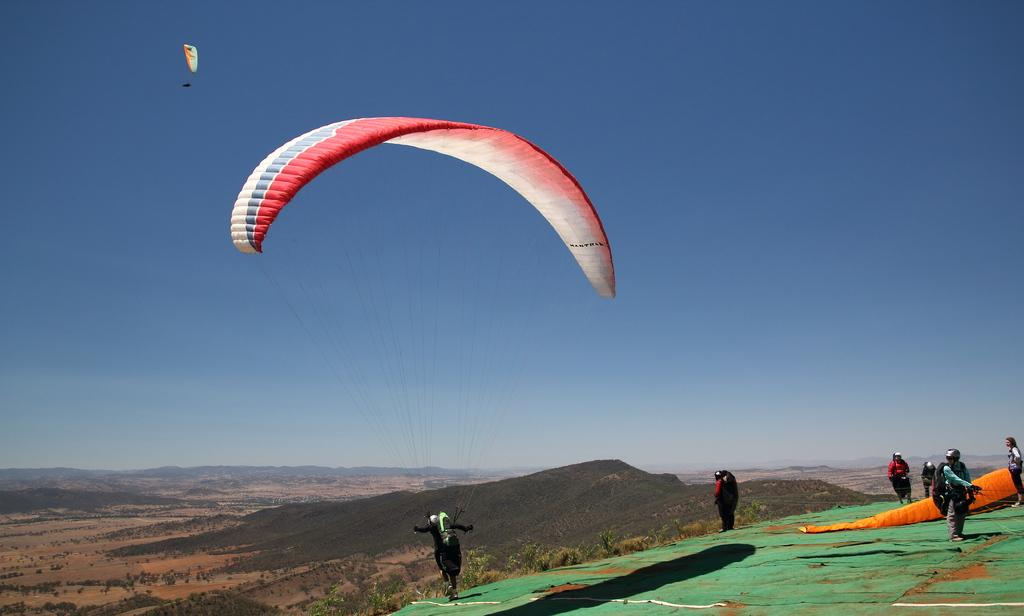Who or what can be seen in the image? There are people in the image. What are the people using in the image? There are parachutes in the image. What type of landscape is visible in the image? There are hills and many trees in the image. What part of the natural environment is visible in the image? The sky is visible in the image. What type of elbow can be seen in the image? There is no elbow present in the image. What type of engine is visible in the image? There is no engine present in the image. 